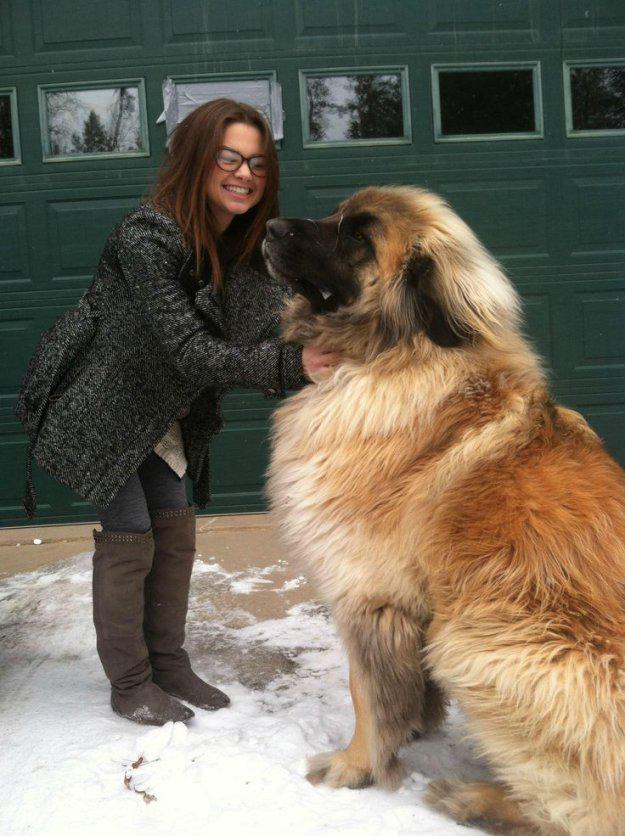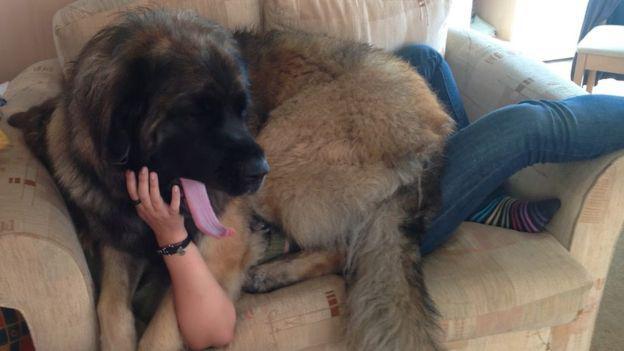The first image is the image on the left, the second image is the image on the right. Given the left and right images, does the statement "There is a human in the image on the right." hold true? Answer yes or no. Yes. 